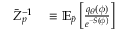<formula> <loc_0><loc_0><loc_500><loc_500>\begin{array} { r l } { \bar { Z } _ { p } ^ { - 1 } } & \equiv \mathbb { E } _ { \widetilde { p } } \left [ \frac { q _ { \theta } ( \phi ) } { e ^ { - S ( \phi ) } } \right ] } \end{array}</formula> 